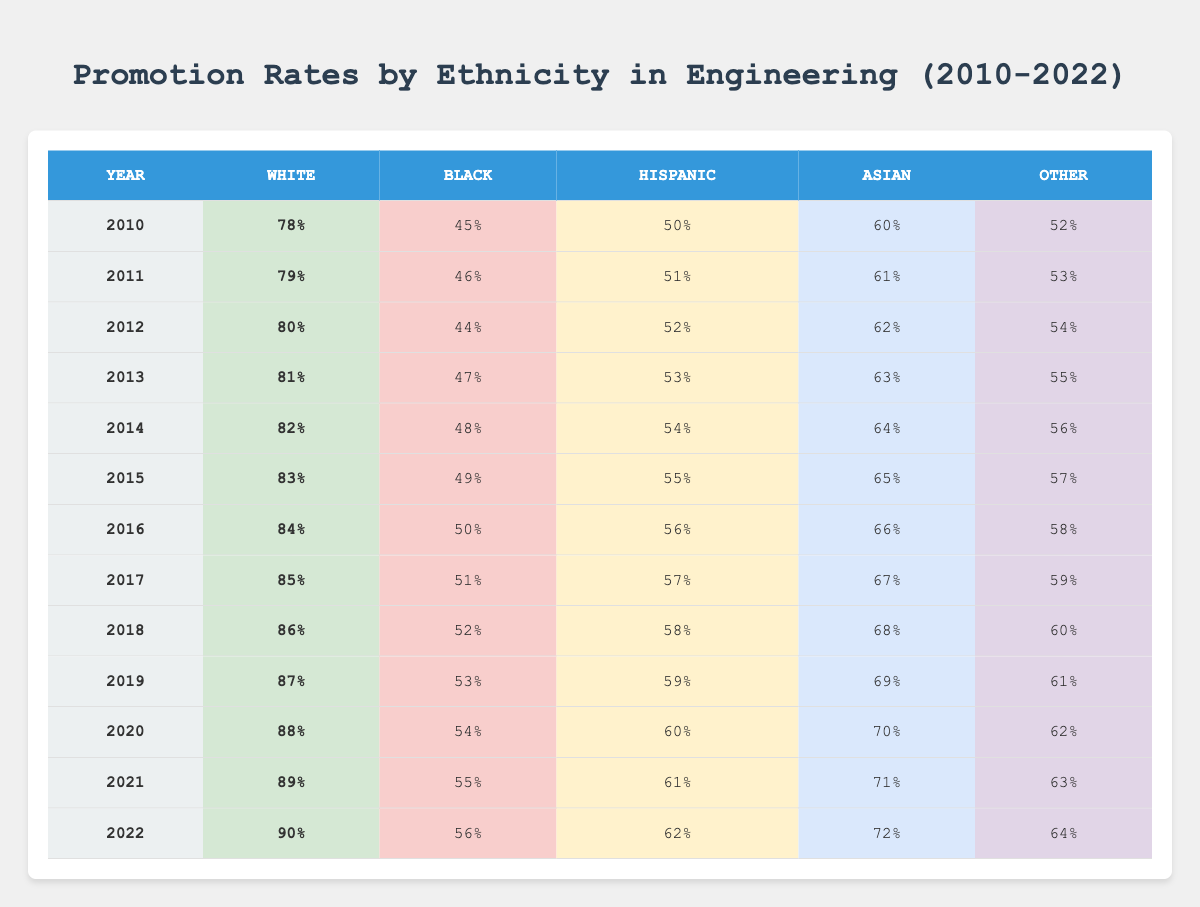What was the promotion rate for White employees in 2010? According to the table, in the year 2010, the promotion rate for White employees is bolded as 78%.
Answer: 78% What was the promotion rate percentage difference between Black and Asian employees in 2015? In 2015, the promotion rate for Black employees is 49% and for Asian employees, it is 65%. The difference is 65% - 49% = 16%.
Answer: 16% In which year did the promotion rate for Hispanic employees first exceed 55%? By examining the table, the promotion rate for Hispanic employees first exceeds 55% in the year 2015, where it is 55%.
Answer: 2015 What is the average promotion rate for Other ethnicity from 2010 to 2022? First, add the promotion rates for Other ethnicity over the years: 52% + 53% + 54% + 55% + 56% + 57% + 58% + 59% + 60% + 61% + 62% + 63% + 64% = 706%. Then, divide by 13 years which equals 706% / 13 = approximately 54.31%.
Answer: 54.31% Did the promotion rate for Black employees ever reach or exceed 60%? Referring to the table, the promotion rate for Black employees never reaches 60% in any of the years listed. The highest recorded rate is 56% in 2022.
Answer: No What year saw the largest increase in promotion rates for White employees compared to the previous year? Looking at the promotion rates for White employees, the largest increase occurs between 2021 and 2022, moving from 89% to 90%, which is a 1% increase.
Answer: 2022 Which ethnicity had the lowest promotion rate in 2010? In 2010, the table shows the lowest promotion rate is for Black employees at 45%.
Answer: Black What is the overall trend in promotion rates for White employees from 2010 to 2022? By observing the table's data for White employees, the promotion rate consistently increases each year, from 78% in 2010 to 90% in 2022. This indicates a positive trend.
Answer: Increasing How many percentage points did the promotion rate for Hispanic employees increase from 2010 to 2022? The promotion rate for Hispanic employees went from 50% in 2010 to 62% in 2022. The increase is 62% - 50% = 12%.
Answer: 12% What proportion of the years saw Black employee promotion rates above 50%? There are 13 total years (2010-2022). The years where Black promotion rates were above 50% are 2017, 2018, 2019, 2020, 2021, and 2022, totaling 6 years. The proportion is 6/13 ≈ 0.46 or about 46%.
Answer: 46% 